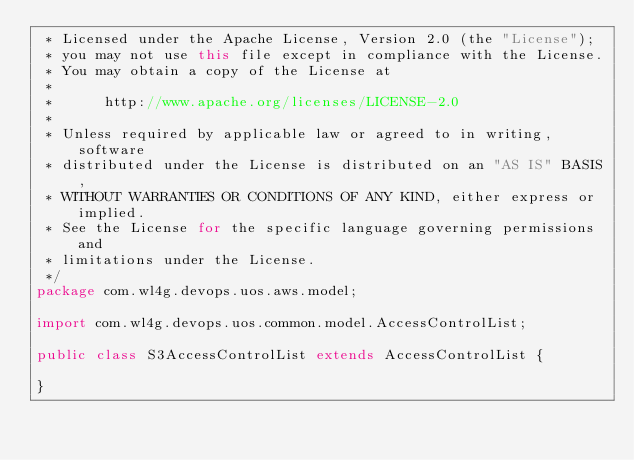Convert code to text. <code><loc_0><loc_0><loc_500><loc_500><_Java_> * Licensed under the Apache License, Version 2.0 (the "License");
 * you may not use this file except in compliance with the License.
 * You may obtain a copy of the License at
 *
 *      http://www.apache.org/licenses/LICENSE-2.0
 *
 * Unless required by applicable law or agreed to in writing, software
 * distributed under the License is distributed on an "AS IS" BASIS,
 * WITHOUT WARRANTIES OR CONDITIONS OF ANY KIND, either express or implied.
 * See the License for the specific language governing permissions and
 * limitations under the License.
 */
package com.wl4g.devops.uos.aws.model;

import com.wl4g.devops.uos.common.model.AccessControlList;

public class S3AccessControlList extends AccessControlList {

}</code> 